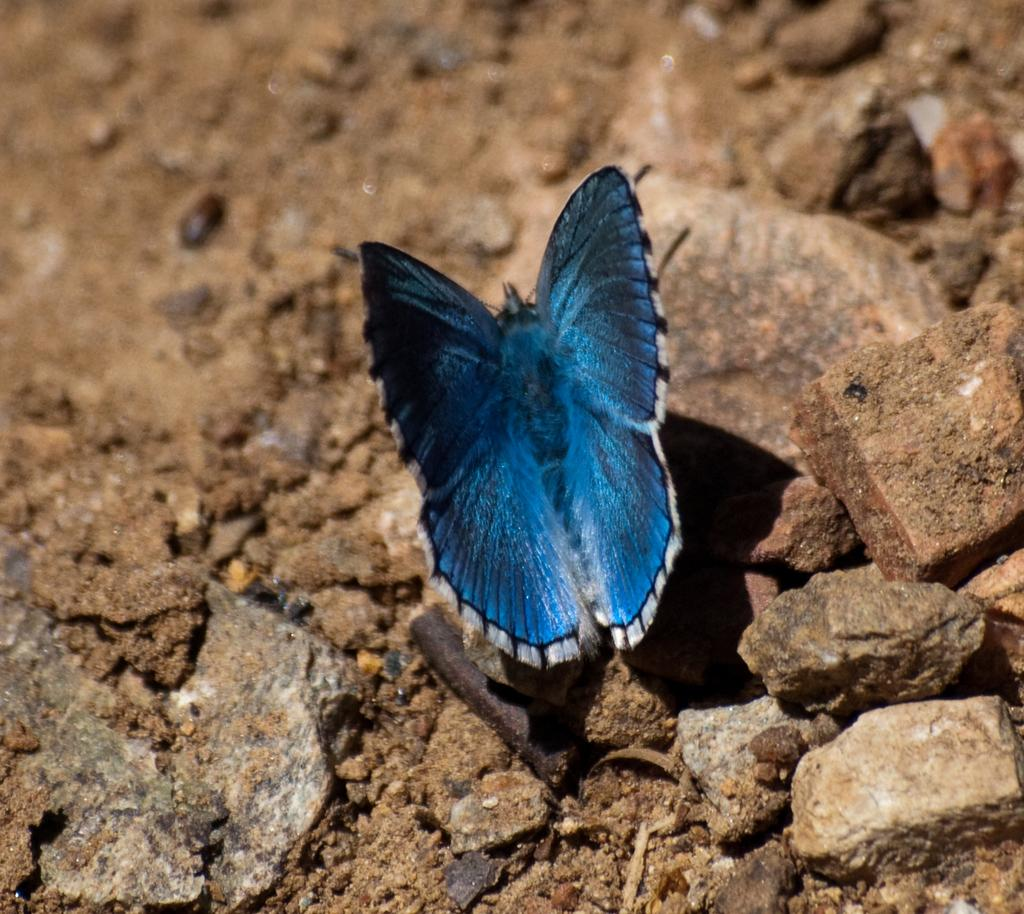What is the main subject of the image? There is a butterfly in the image. Where is the butterfly located? The butterfly is on a rock. What part of the ship can be seen in the image? There is no ship present in the image; it features a butterfly on a rock. What type of thunder can be heard in the image? There is no thunder present in the image; it features a butterfly on a rock. 